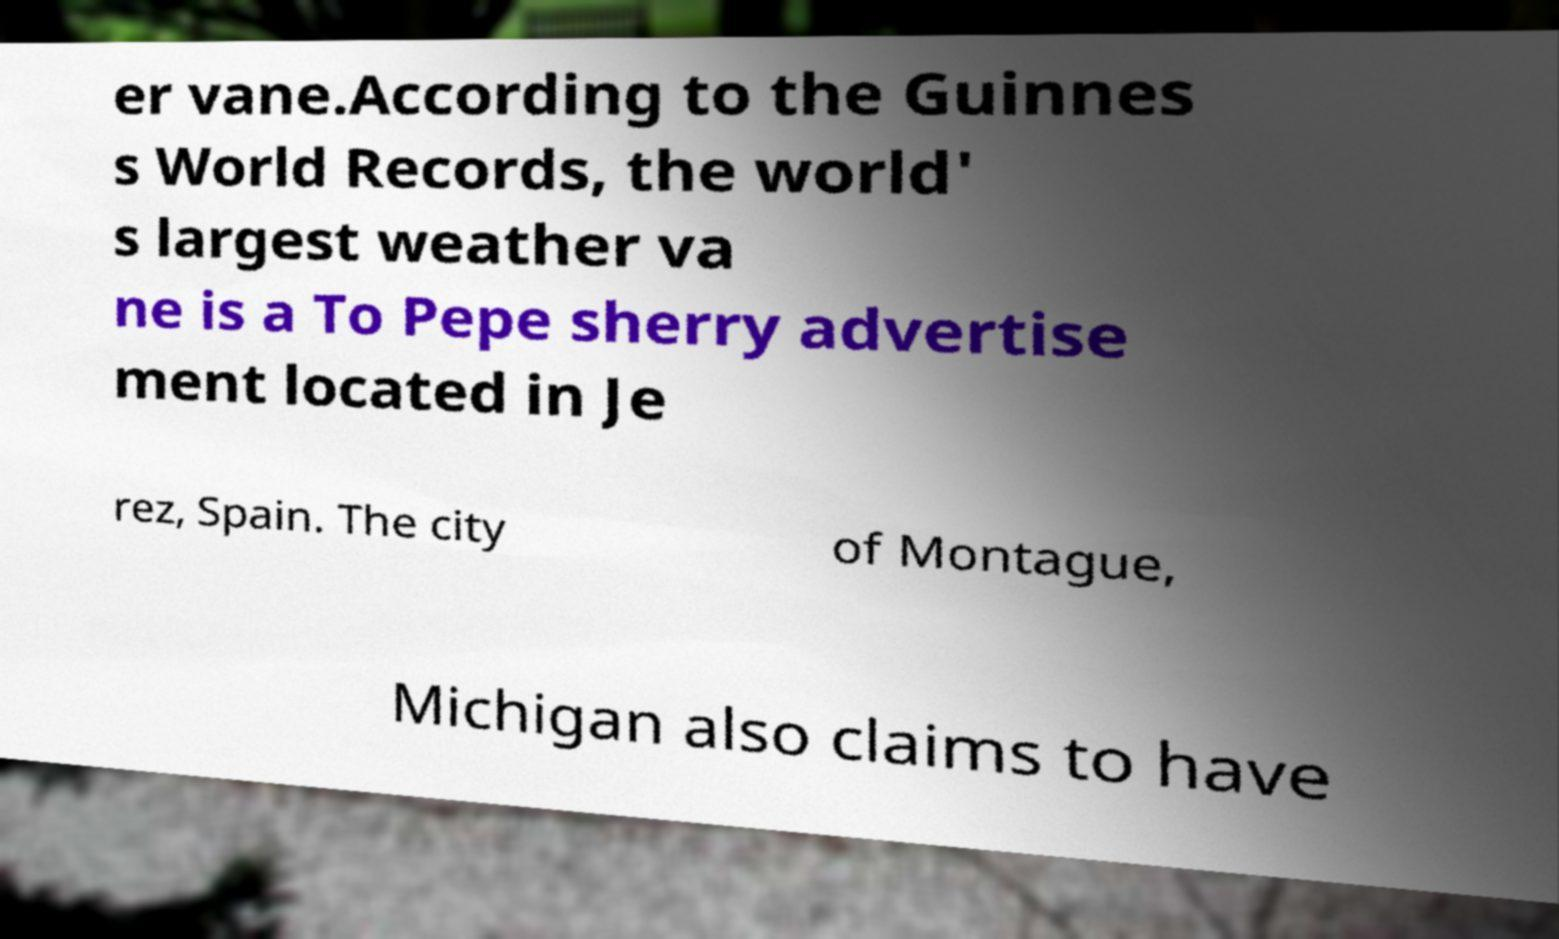Could you assist in decoding the text presented in this image and type it out clearly? er vane.According to the Guinnes s World Records, the world' s largest weather va ne is a To Pepe sherry advertise ment located in Je rez, Spain. The city of Montague, Michigan also claims to have 